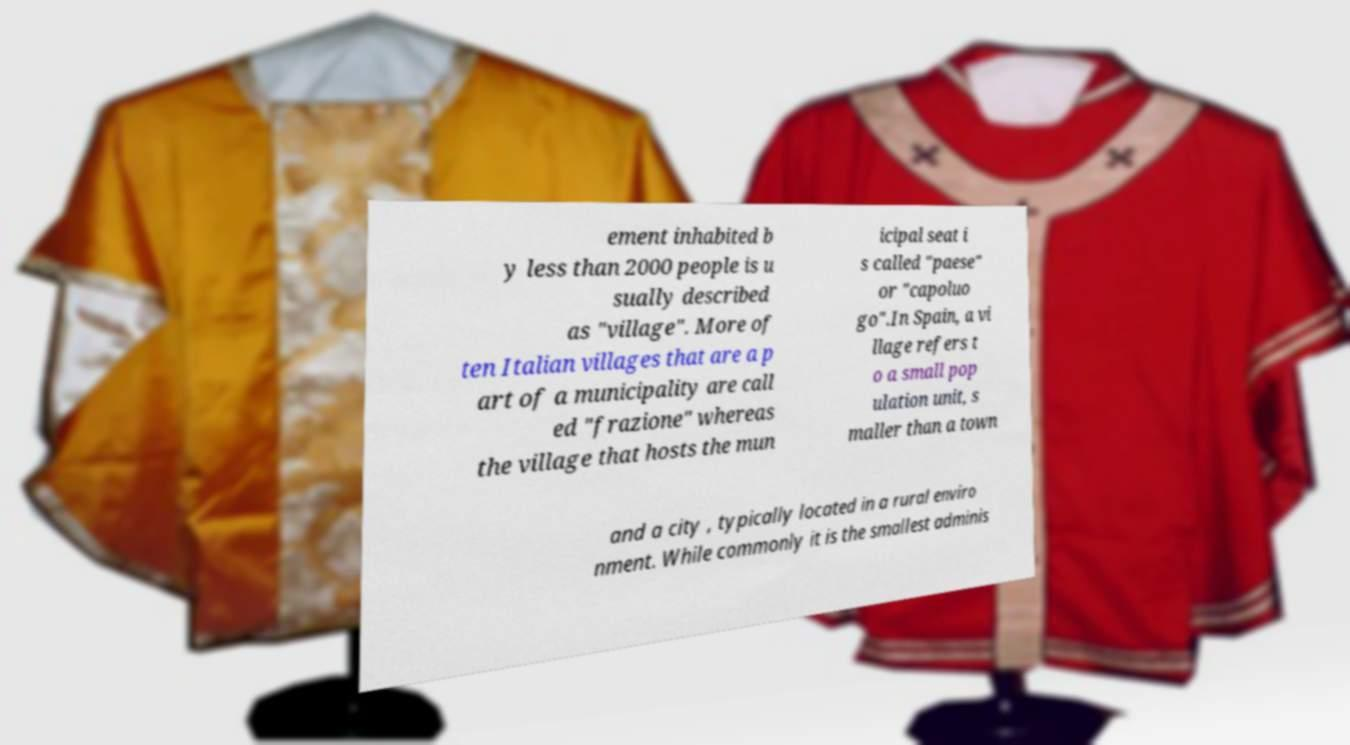Could you extract and type out the text from this image? ement inhabited b y less than 2000 people is u sually described as "village". More of ten Italian villages that are a p art of a municipality are call ed "frazione" whereas the village that hosts the mun icipal seat i s called "paese" or "capoluo go".In Spain, a vi llage refers t o a small pop ulation unit, s maller than a town and a city , typically located in a rural enviro nment. While commonly it is the smallest adminis 